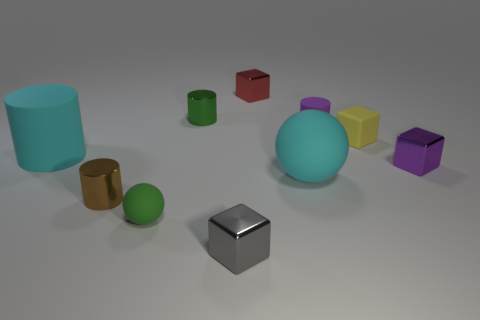Subtract 1 cylinders. How many cylinders are left? 3 Subtract all cubes. How many objects are left? 6 Add 7 big yellow objects. How many big yellow objects exist? 7 Subtract 0 blue cubes. How many objects are left? 10 Subtract all tiny matte objects. Subtract all brown cylinders. How many objects are left? 6 Add 2 purple blocks. How many purple blocks are left? 3 